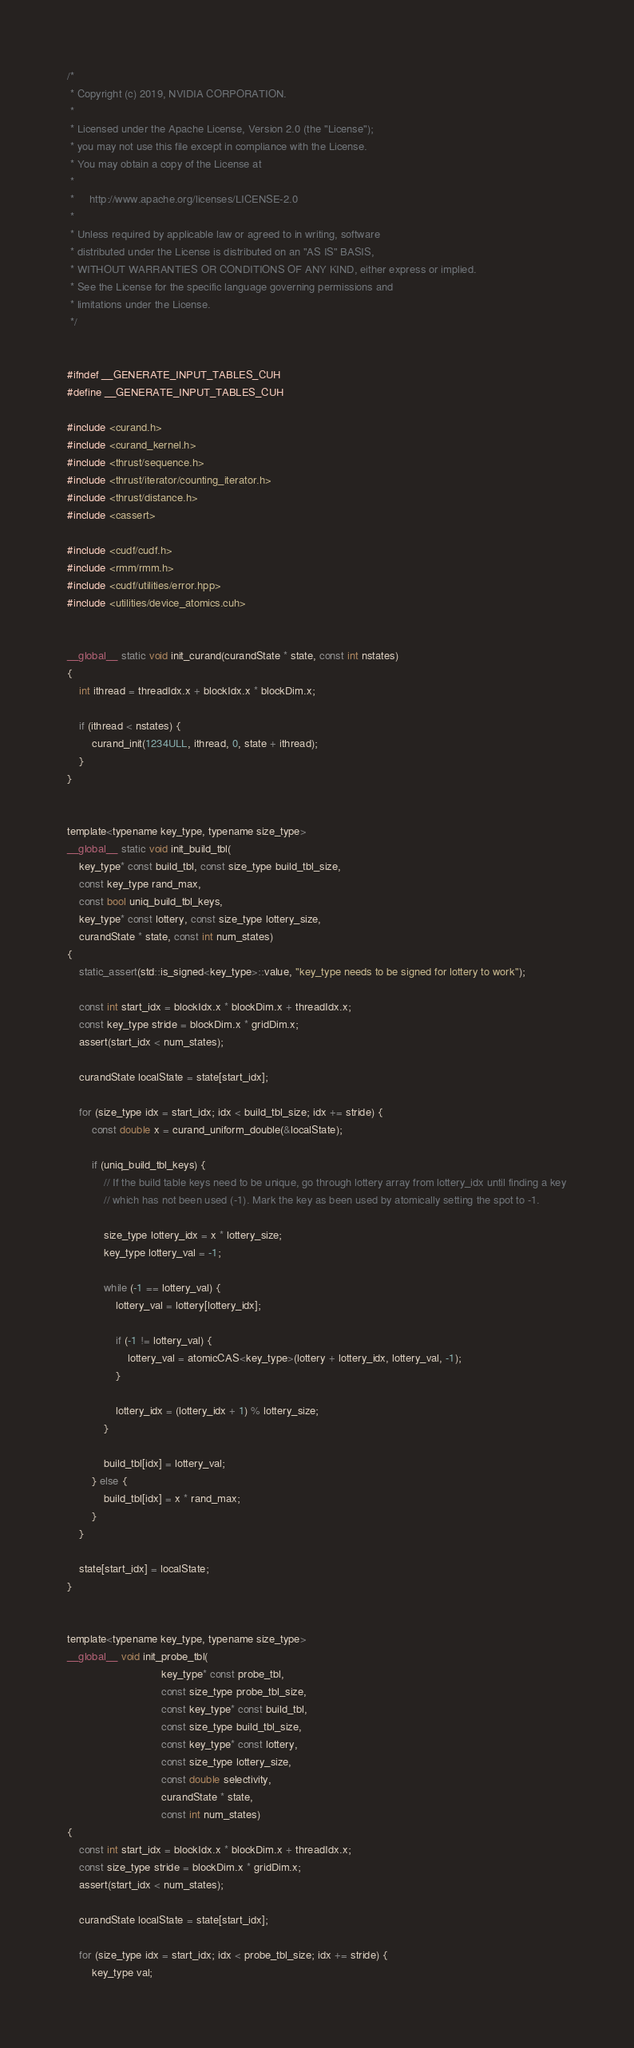Convert code to text. <code><loc_0><loc_0><loc_500><loc_500><_Cuda_>/*
 * Copyright (c) 2019, NVIDIA CORPORATION.
 *
 * Licensed under the Apache License, Version 2.0 (the "License");
 * you may not use this file except in compliance with the License.
 * You may obtain a copy of the License at
 *
 *     http://www.apache.org/licenses/LICENSE-2.0
 *
 * Unless required by applicable law or agreed to in writing, software
 * distributed under the License is distributed on an "AS IS" BASIS,
 * WITHOUT WARRANTIES OR CONDITIONS OF ANY KIND, either express or implied.
 * See the License for the specific language governing permissions and
 * limitations under the License.
 */


#ifndef __GENERATE_INPUT_TABLES_CUH
#define __GENERATE_INPUT_TABLES_CUH

#include <curand.h>
#include <curand_kernel.h>
#include <thrust/sequence.h>
#include <thrust/iterator/counting_iterator.h>
#include <thrust/distance.h>
#include <cassert>

#include <cudf/cudf.h>
#include <rmm/rmm.h>
#include <cudf/utilities/error.hpp>
#include <utilities/device_atomics.cuh>


__global__ static void init_curand(curandState * state, const int nstates)
{
    int ithread = threadIdx.x + blockIdx.x * blockDim.x;

    if (ithread < nstates) {
        curand_init(1234ULL, ithread, 0, state + ithread);
    }
}


template<typename key_type, typename size_type>
__global__ static void init_build_tbl(
    key_type* const build_tbl, const size_type build_tbl_size,
    const key_type rand_max,
    const bool uniq_build_tbl_keys,
    key_type* const lottery, const size_type lottery_size,
    curandState * state, const int num_states)
{
    static_assert(std::is_signed<key_type>::value, "key_type needs to be signed for lottery to work");

    const int start_idx = blockIdx.x * blockDim.x + threadIdx.x;
    const key_type stride = blockDim.x * gridDim.x;
    assert(start_idx < num_states);

    curandState localState = state[start_idx];

    for (size_type idx = start_idx; idx < build_tbl_size; idx += stride) {
        const double x = curand_uniform_double(&localState);

        if (uniq_build_tbl_keys) {
	        // If the build table keys need to be unique, go through lottery array from lottery_idx until finding a key
            // which has not been used (-1). Mark the key as been used by atomically setting the spot to -1.

            size_type lottery_idx = x * lottery_size;
            key_type lottery_val = -1;

            while (-1 == lottery_val) {
                lottery_val = lottery[lottery_idx];

                if (-1 != lottery_val) {
                    lottery_val = atomicCAS<key_type>(lottery + lottery_idx, lottery_val, -1);
                }

                lottery_idx = (lottery_idx + 1) % lottery_size;
            }

            build_tbl[idx] = lottery_val;
        } else {
            build_tbl[idx] = x * rand_max;
        }
    }

    state[start_idx] = localState;
}


template<typename key_type, typename size_type>
__global__ void init_probe_tbl(
                               key_type* const probe_tbl,
                               const size_type probe_tbl_size,
                               const key_type* const build_tbl,
                               const size_type build_tbl_size,
                               const key_type* const lottery,
                               const size_type lottery_size,
                               const double selectivity,
                               curandState * state,
                               const int num_states)
{
    const int start_idx = blockIdx.x * blockDim.x + threadIdx.x;
    const size_type stride = blockDim.x * gridDim.x;
    assert(start_idx < num_states);

    curandState localState = state[start_idx];

    for (size_type idx = start_idx; idx < probe_tbl_size; idx += stride) {
        key_type val;</code> 